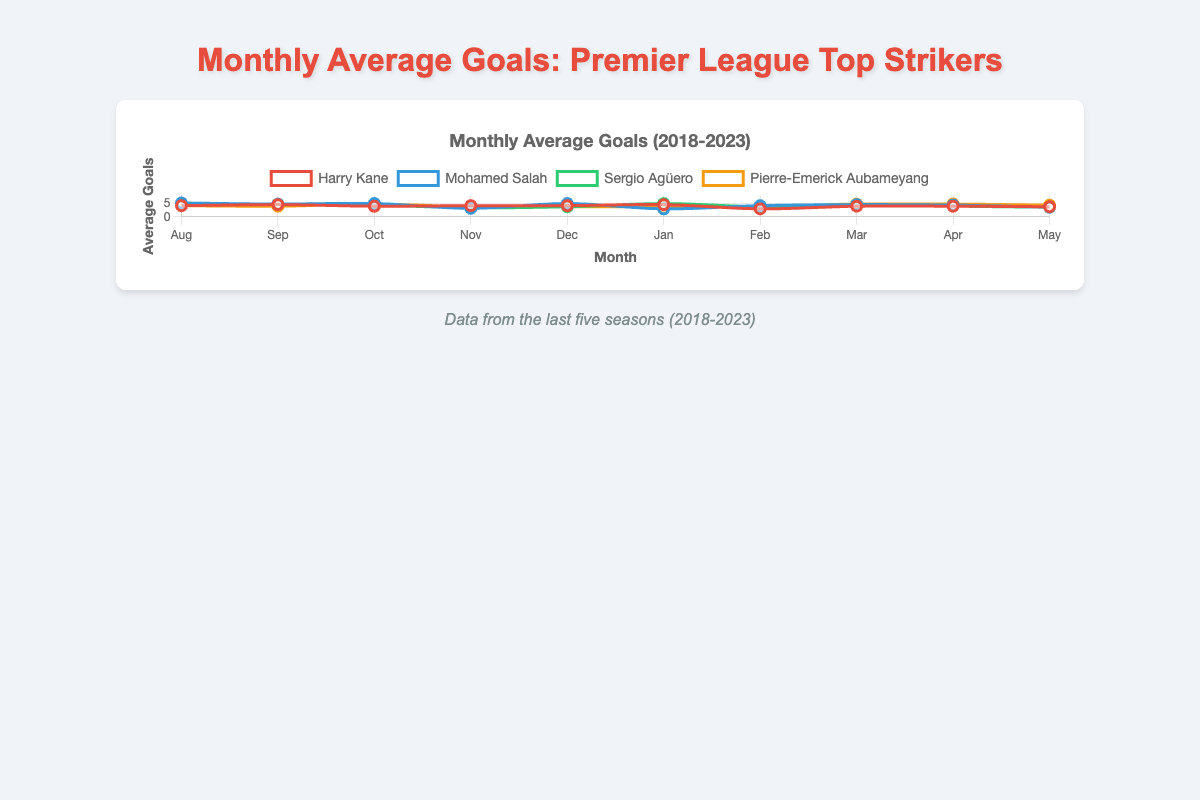Which player has the highest average goals in a single month? Looking at the chart, we compare the peaks of each player's line. The highest average monthly goals scored are 7 by Mohamed Salah in December of the 2018-2019 season.
Answer: Mohamed Salah In which month does Harry Kane show the lowest scoring average? Referring to the Harry Kane line (red), the lowest point is in February with an average of 2 goals.
Answer: February Who scored more goals on average in October, Harry Kane or Sergio Agüero? We compare the average goals in October for both players. Harry Kane averages 4 goals, while Sergio Agüero averages 4.6 goals.
Answer: Sergio Agüero What’s the total average monthly goals scored by Pierre-Emerick Aubameyang in the 2022-2023 season? Summing up the average goals of each month for 2022-2023: 3 + 5 + 6 + 2 + 4 + 5 + 3 + 6 + 5 + 4 = 43. The total average is then divided by the number of months (10), resulting in 43/10 = 4.3.
Answer: 4.3 In which month did Mohamed Salah perform best across the seasons? Observing the months where the blue line (Mohamed Salah) peaks, the highest single average is 6 goals, appearing in August and June across different seasons.
Answer: August or June Comparing the performance across November, who scores better on average: Mohamed Salah or Pierre-Emerick Aubameyang? For November, checking the blue and orange lines, Mohamed Salah averages 3, while Aubameyang averages 3.6 goals.
Answer: Pierre-Emerick Aubameyang How does Harry Kane's performance in March compare to his performance in January? Refer to Harry Kane's (red line) average goals for both months. In January, he scores an average of 5 goals, while in March he scores an average of 3.
Answer: January What is the most common monthly average goal count for Sergio Agüero? Analyzing the green line (Sergio Agüero), the most common (modal) monthly average occurs at 4 goals.
Answer: 4 Who shows a higher increase in average goals from April to May, Harry Kane or Mohamed Salah? For Harry Kane, April to May shows a change from an average of 4 to 3 goals, a decrease. For Salah, April to May shows a change from 5 to 2 goals, also a decrease. However, Kane's decrease is less significant than Salah’s.
Answer: Harry Kane What's the smallest average goal count observed for any player in any month and which player does it belong to? From the chart, the smallest average monthly goal count is 2, observed for Harry Kane (red line in several months) and some other players depending on the season.
Answer: Harry Kane 